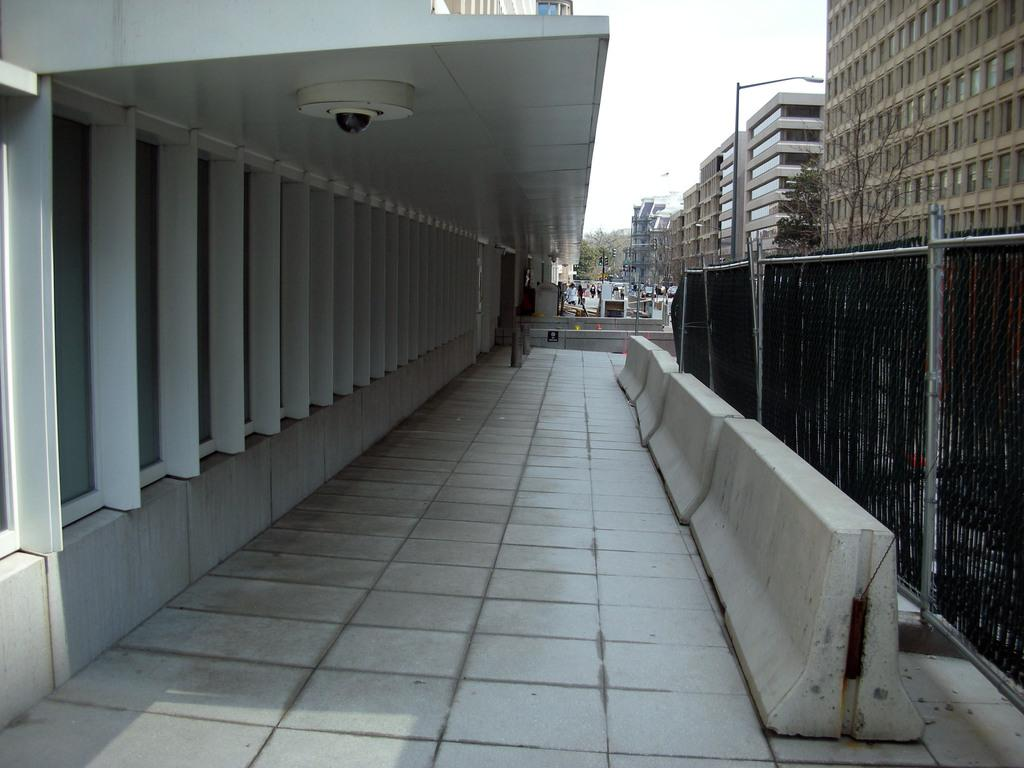What type of structures can be seen in the image? There are buildings in the image. Where is the camera located in the image? The camera is on the ceiling in the image. What can be seen separating different areas in the image? There is a fence in the image. What type of vegetation is present in the image? There are trees in the image. What type of lighting is present in the image? There are street lights in the image. What other objects can be seen on the ground in the image? There are other objects on the ground in the image. What can be seen in the background of the image? The sky is visible in the background of the image. What type of glue is being used to hold the buildings together in the image? There is no glue present in the image; the buildings are held together by their construction materials. What type of jam is being spread on the trees in the image? There is no jam present in the image; the trees are natural vegetation. 